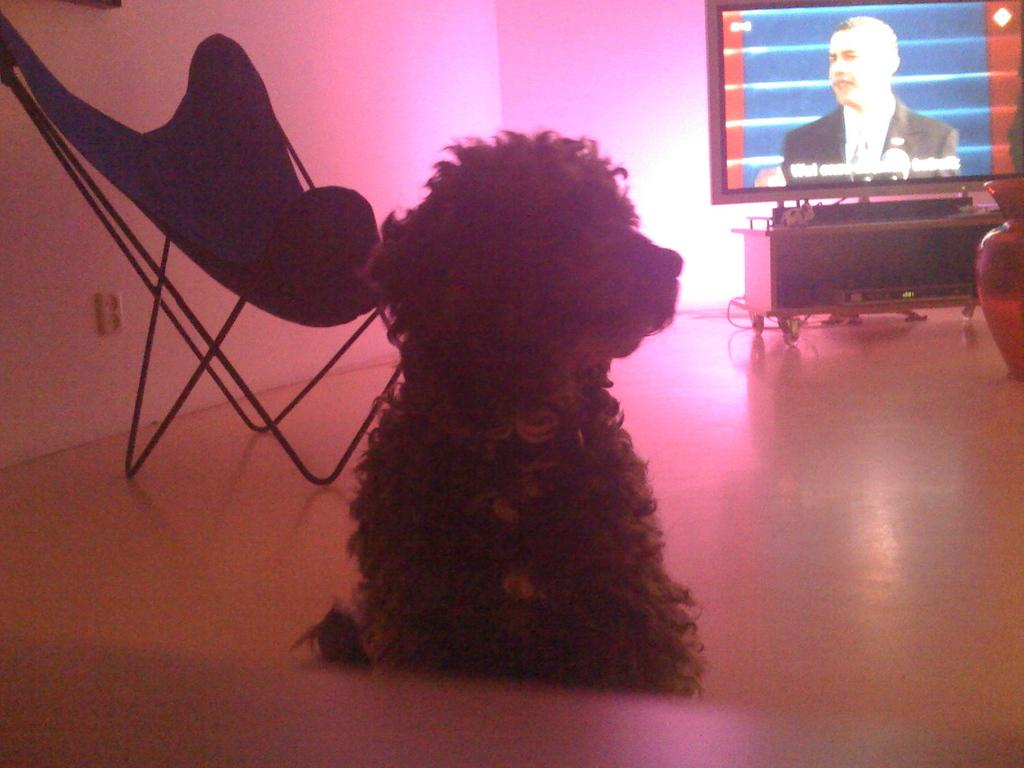What animal is located in the middle of the image? There is a dog in the middle of the image. What electronic device is on the right side of the image? There is a television on the right side of the image. What type of furniture is on the left side of the image? There is a chair on the left side of the image. What type of jellyfish can be seen swimming in the image? There is no jellyfish present in the image; it features a dog, a television, and a chair. How does the horse contribute to the image? There is no horse present in the image. 